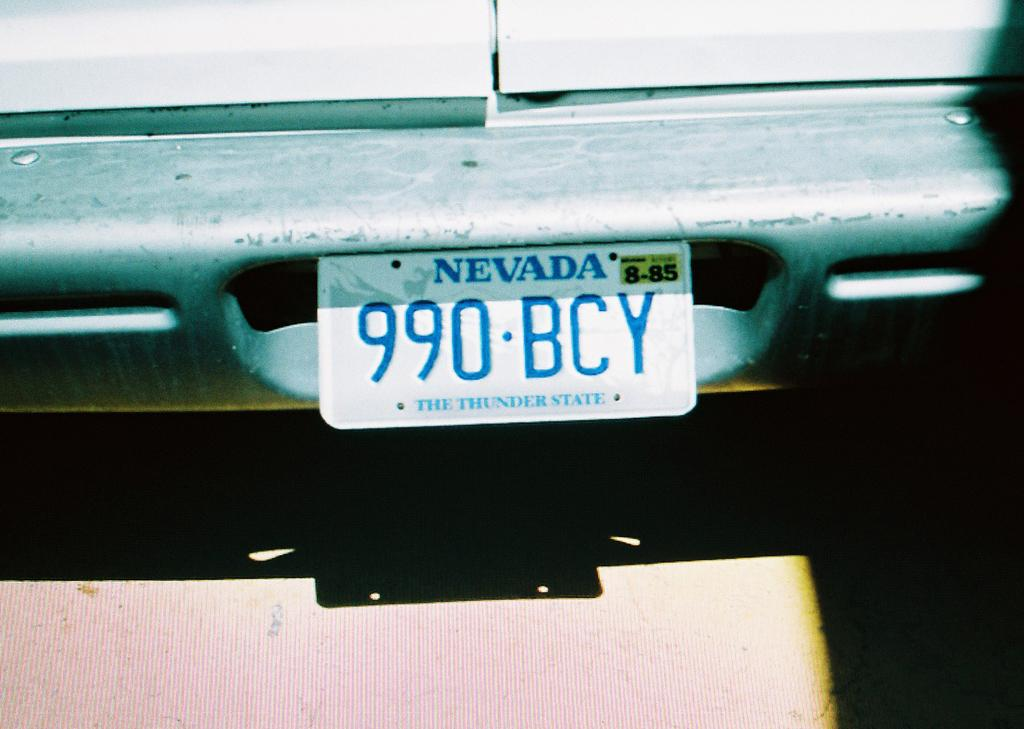<image>
Summarize the visual content of the image. The car is from Nevada, with license plate number 990 BCY. 